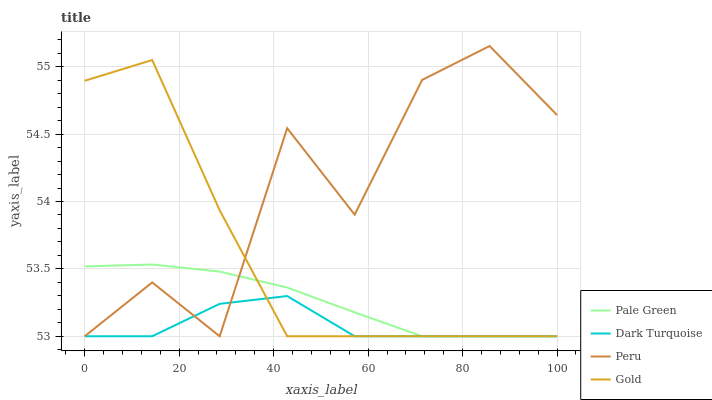Does Dark Turquoise have the minimum area under the curve?
Answer yes or no. Yes. Does Peru have the maximum area under the curve?
Answer yes or no. Yes. Does Pale Green have the minimum area under the curve?
Answer yes or no. No. Does Pale Green have the maximum area under the curve?
Answer yes or no. No. Is Pale Green the smoothest?
Answer yes or no. Yes. Is Peru the roughest?
Answer yes or no. Yes. Is Gold the smoothest?
Answer yes or no. No. Is Gold the roughest?
Answer yes or no. No. Does Peru have the highest value?
Answer yes or no. Yes. Does Pale Green have the highest value?
Answer yes or no. No. Does Pale Green intersect Dark Turquoise?
Answer yes or no. Yes. Is Pale Green less than Dark Turquoise?
Answer yes or no. No. Is Pale Green greater than Dark Turquoise?
Answer yes or no. No. 